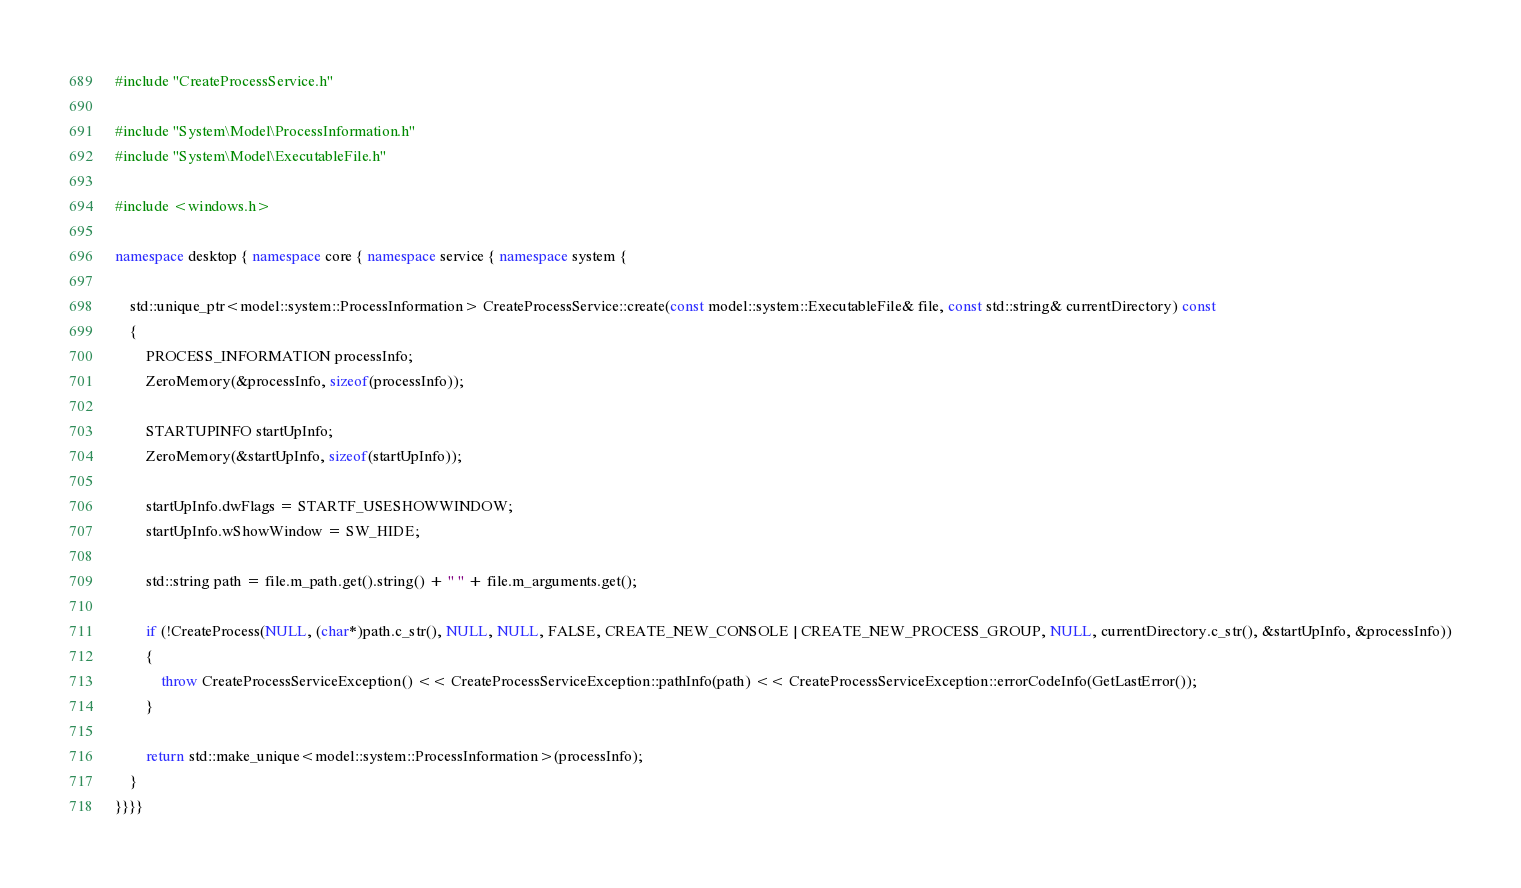Convert code to text. <code><loc_0><loc_0><loc_500><loc_500><_C++_>#include "CreateProcessService.h"

#include "System\Model\ProcessInformation.h"
#include "System\Model\ExecutableFile.h"

#include <windows.h>

namespace desktop { namespace core { namespace service { namespace system {

	std::unique_ptr<model::system::ProcessInformation> CreateProcessService::create(const model::system::ExecutableFile& file, const std::string& currentDirectory) const
	{
		PROCESS_INFORMATION processInfo;
		ZeroMemory(&processInfo, sizeof(processInfo));

		STARTUPINFO startUpInfo;
		ZeroMemory(&startUpInfo, sizeof(startUpInfo));

		startUpInfo.dwFlags = STARTF_USESHOWWINDOW;
		startUpInfo.wShowWindow = SW_HIDE;

		std::string path = file.m_path.get().string() + " " + file.m_arguments.get();

		if (!CreateProcess(NULL, (char*)path.c_str(), NULL, NULL, FALSE, CREATE_NEW_CONSOLE | CREATE_NEW_PROCESS_GROUP, NULL, currentDirectory.c_str(), &startUpInfo, &processInfo))
		{
			throw CreateProcessServiceException() << CreateProcessServiceException::pathInfo(path) << CreateProcessServiceException::errorCodeInfo(GetLastError());
		}

		return std::make_unique<model::system::ProcessInformation>(processInfo);
	}
}}}}
</code> 